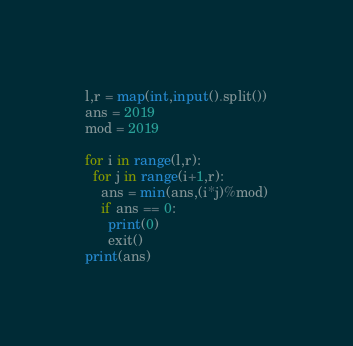Convert code to text. <code><loc_0><loc_0><loc_500><loc_500><_Python_>l,r = map(int,input().split())
ans = 2019
mod = 2019
 
for i in range(l,r):
  for j in range(i+1,r):
    ans = min(ans,(i*j)%mod)
    if ans == 0:
      print(0)
      exit()
print(ans)</code> 